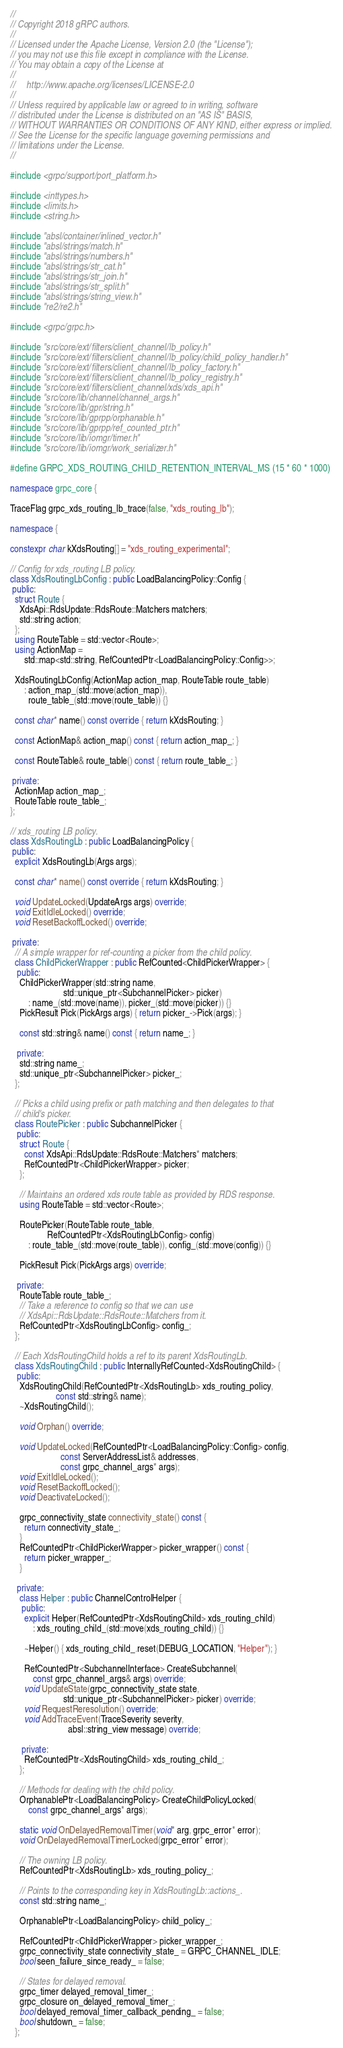<code> <loc_0><loc_0><loc_500><loc_500><_C++_>//
// Copyright 2018 gRPC authors.
//
// Licensed under the Apache License, Version 2.0 (the "License");
// you may not use this file except in compliance with the License.
// You may obtain a copy of the License at
//
//     http://www.apache.org/licenses/LICENSE-2.0
//
// Unless required by applicable law or agreed to in writing, software
// distributed under the License is distributed on an "AS IS" BASIS,
// WITHOUT WARRANTIES OR CONDITIONS OF ANY KIND, either express or implied.
// See the License for the specific language governing permissions and
// limitations under the License.
//

#include <grpc/support/port_platform.h>

#include <inttypes.h>
#include <limits.h>
#include <string.h>

#include "absl/container/inlined_vector.h"
#include "absl/strings/match.h"
#include "absl/strings/numbers.h"
#include "absl/strings/str_cat.h"
#include "absl/strings/str_join.h"
#include "absl/strings/str_split.h"
#include "absl/strings/string_view.h"
#include "re2/re2.h"

#include <grpc/grpc.h>

#include "src/core/ext/filters/client_channel/lb_policy.h"
#include "src/core/ext/filters/client_channel/lb_policy/child_policy_handler.h"
#include "src/core/ext/filters/client_channel/lb_policy_factory.h"
#include "src/core/ext/filters/client_channel/lb_policy_registry.h"
#include "src/core/ext/filters/client_channel/xds/xds_api.h"
#include "src/core/lib/channel/channel_args.h"
#include "src/core/lib/gpr/string.h"
#include "src/core/lib/gprpp/orphanable.h"
#include "src/core/lib/gprpp/ref_counted_ptr.h"
#include "src/core/lib/iomgr/timer.h"
#include "src/core/lib/iomgr/work_serializer.h"

#define GRPC_XDS_ROUTING_CHILD_RETENTION_INTERVAL_MS (15 * 60 * 1000)

namespace grpc_core {

TraceFlag grpc_xds_routing_lb_trace(false, "xds_routing_lb");

namespace {

constexpr char kXdsRouting[] = "xds_routing_experimental";

// Config for xds_routing LB policy.
class XdsRoutingLbConfig : public LoadBalancingPolicy::Config {
 public:
  struct Route {
    XdsApi::RdsUpdate::RdsRoute::Matchers matchers;
    std::string action;
  };
  using RouteTable = std::vector<Route>;
  using ActionMap =
      std::map<std::string, RefCountedPtr<LoadBalancingPolicy::Config>>;

  XdsRoutingLbConfig(ActionMap action_map, RouteTable route_table)
      : action_map_(std::move(action_map)),
        route_table_(std::move(route_table)) {}

  const char* name() const override { return kXdsRouting; }

  const ActionMap& action_map() const { return action_map_; }

  const RouteTable& route_table() const { return route_table_; }

 private:
  ActionMap action_map_;
  RouteTable route_table_;
};

// xds_routing LB policy.
class XdsRoutingLb : public LoadBalancingPolicy {
 public:
  explicit XdsRoutingLb(Args args);

  const char* name() const override { return kXdsRouting; }

  void UpdateLocked(UpdateArgs args) override;
  void ExitIdleLocked() override;
  void ResetBackoffLocked() override;

 private:
  // A simple wrapper for ref-counting a picker from the child policy.
  class ChildPickerWrapper : public RefCounted<ChildPickerWrapper> {
   public:
    ChildPickerWrapper(std::string name,
                       std::unique_ptr<SubchannelPicker> picker)
        : name_(std::move(name)), picker_(std::move(picker)) {}
    PickResult Pick(PickArgs args) { return picker_->Pick(args); }

    const std::string& name() const { return name_; }

   private:
    std::string name_;
    std::unique_ptr<SubchannelPicker> picker_;
  };

  // Picks a child using prefix or path matching and then delegates to that
  // child's picker.
  class RoutePicker : public SubchannelPicker {
   public:
    struct Route {
      const XdsApi::RdsUpdate::RdsRoute::Matchers* matchers;
      RefCountedPtr<ChildPickerWrapper> picker;
    };

    // Maintains an ordered xds route table as provided by RDS response.
    using RouteTable = std::vector<Route>;

    RoutePicker(RouteTable route_table,
                RefCountedPtr<XdsRoutingLbConfig> config)
        : route_table_(std::move(route_table)), config_(std::move(config)) {}

    PickResult Pick(PickArgs args) override;

   private:
    RouteTable route_table_;
    // Take a reference to config so that we can use
    // XdsApi::RdsUpdate::RdsRoute::Matchers from it.
    RefCountedPtr<XdsRoutingLbConfig> config_;
  };

  // Each XdsRoutingChild holds a ref to its parent XdsRoutingLb.
  class XdsRoutingChild : public InternallyRefCounted<XdsRoutingChild> {
   public:
    XdsRoutingChild(RefCountedPtr<XdsRoutingLb> xds_routing_policy,
                    const std::string& name);
    ~XdsRoutingChild();

    void Orphan() override;

    void UpdateLocked(RefCountedPtr<LoadBalancingPolicy::Config> config,
                      const ServerAddressList& addresses,
                      const grpc_channel_args* args);
    void ExitIdleLocked();
    void ResetBackoffLocked();
    void DeactivateLocked();

    grpc_connectivity_state connectivity_state() const {
      return connectivity_state_;
    }
    RefCountedPtr<ChildPickerWrapper> picker_wrapper() const {
      return picker_wrapper_;
    }

   private:
    class Helper : public ChannelControlHelper {
     public:
      explicit Helper(RefCountedPtr<XdsRoutingChild> xds_routing_child)
          : xds_routing_child_(std::move(xds_routing_child)) {}

      ~Helper() { xds_routing_child_.reset(DEBUG_LOCATION, "Helper"); }

      RefCountedPtr<SubchannelInterface> CreateSubchannel(
          const grpc_channel_args& args) override;
      void UpdateState(grpc_connectivity_state state,
                       std::unique_ptr<SubchannelPicker> picker) override;
      void RequestReresolution() override;
      void AddTraceEvent(TraceSeverity severity,
                         absl::string_view message) override;

     private:
      RefCountedPtr<XdsRoutingChild> xds_routing_child_;
    };

    // Methods for dealing with the child policy.
    OrphanablePtr<LoadBalancingPolicy> CreateChildPolicyLocked(
        const grpc_channel_args* args);

    static void OnDelayedRemovalTimer(void* arg, grpc_error* error);
    void OnDelayedRemovalTimerLocked(grpc_error* error);

    // The owning LB policy.
    RefCountedPtr<XdsRoutingLb> xds_routing_policy_;

    // Points to the corresponding key in XdsRoutingLb::actions_.
    const std::string name_;

    OrphanablePtr<LoadBalancingPolicy> child_policy_;

    RefCountedPtr<ChildPickerWrapper> picker_wrapper_;
    grpc_connectivity_state connectivity_state_ = GRPC_CHANNEL_IDLE;
    bool seen_failure_since_ready_ = false;

    // States for delayed removal.
    grpc_timer delayed_removal_timer_;
    grpc_closure on_delayed_removal_timer_;
    bool delayed_removal_timer_callback_pending_ = false;
    bool shutdown_ = false;
  };
</code> 